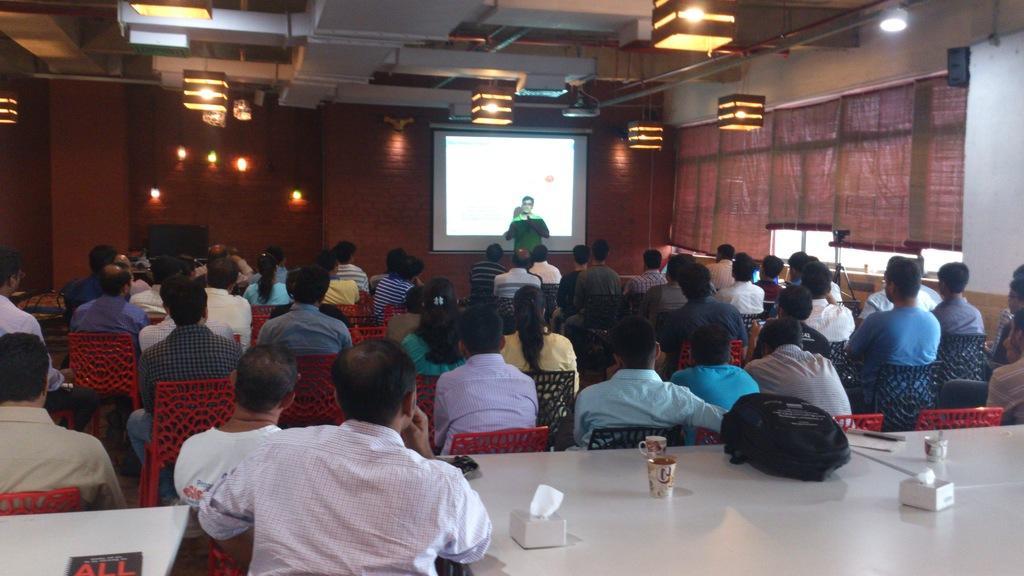Can you describe this image briefly? In this picture we can see a group of people sitting on chairs, tables with a big, glass, cups, tissue paper boxes on it and in front of them we can see a man standing, screen, lights, walls, windows with curtains, ceiling and some objects. 